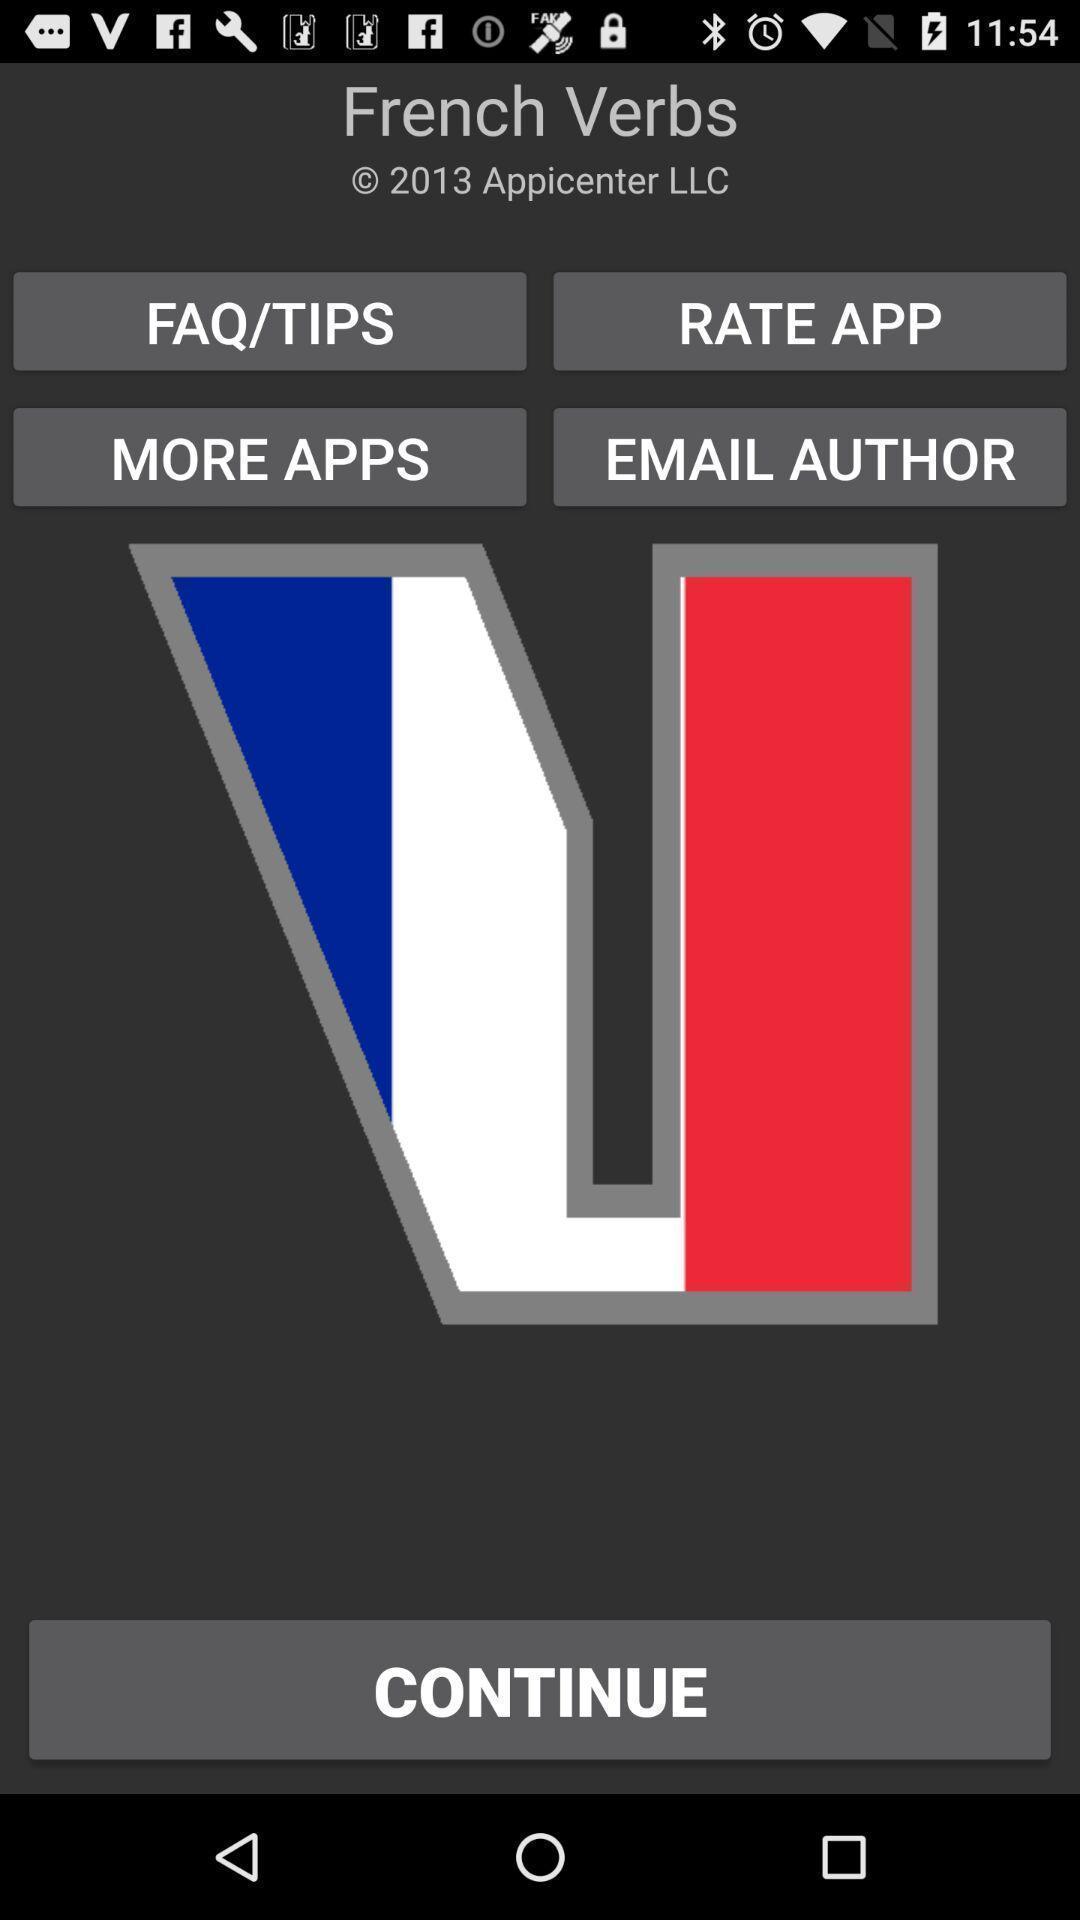Please provide a description for this image. Screen showing the welcome page of language verbs app. 